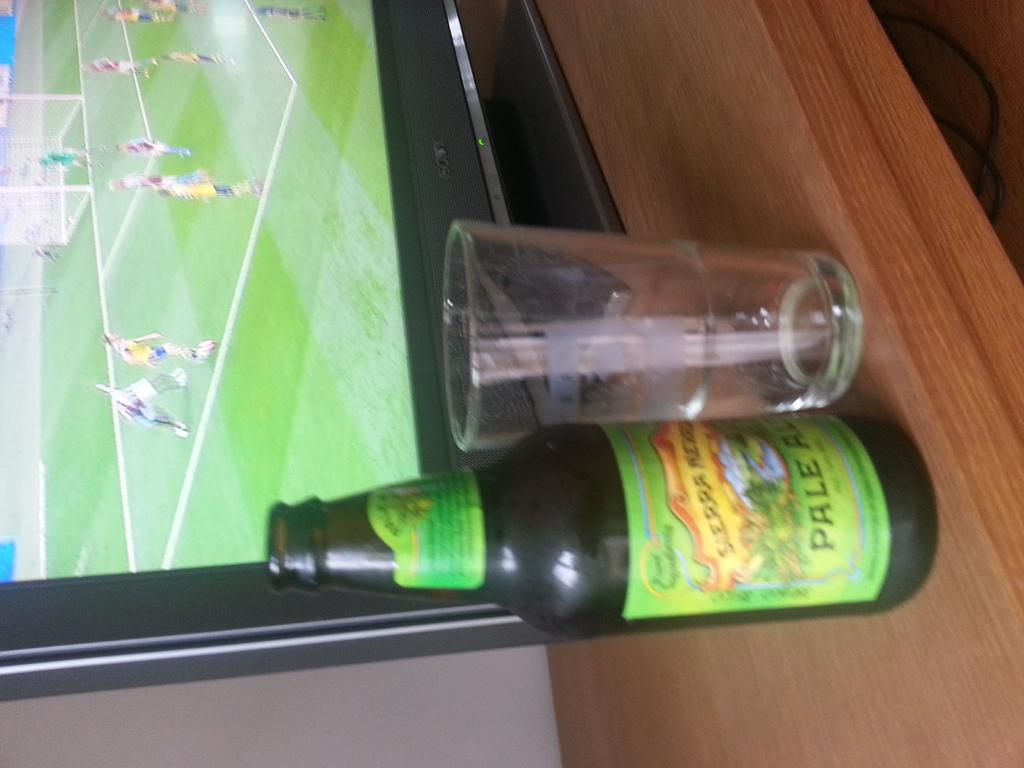<image>
Share a concise interpretation of the image provided. A bottle with a green label that says pale ale. 